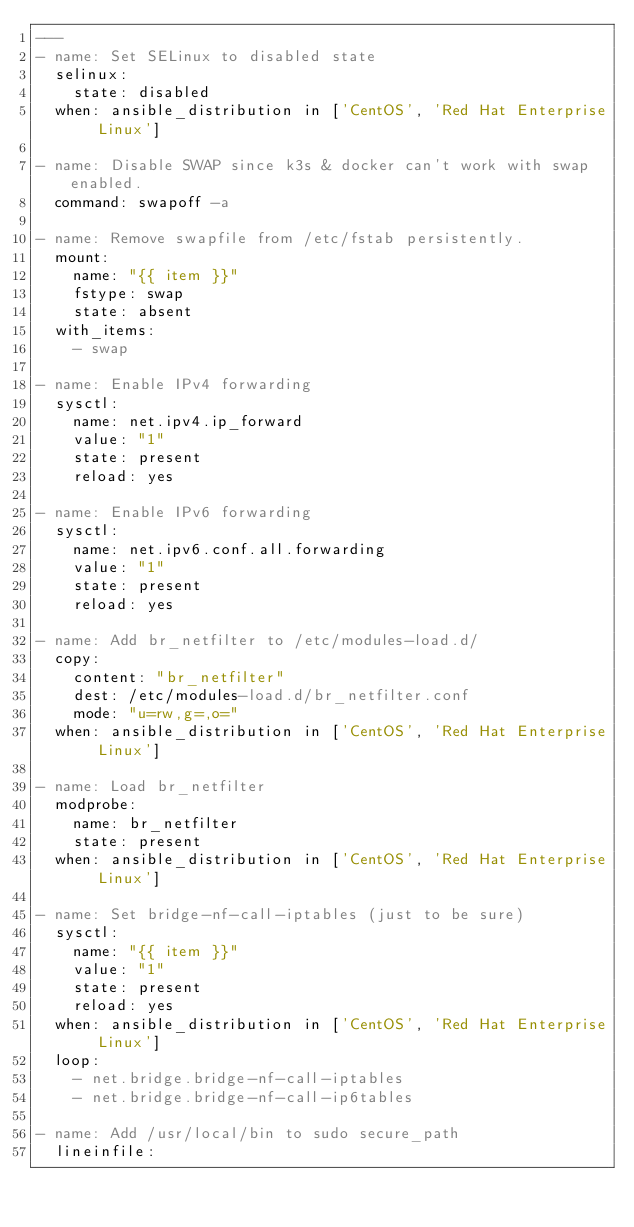<code> <loc_0><loc_0><loc_500><loc_500><_YAML_>---
- name: Set SELinux to disabled state
  selinux:
    state: disabled
  when: ansible_distribution in ['CentOS', 'Red Hat Enterprise Linux']

- name: Disable SWAP since k3s & docker can't work with swap enabled.
  command: swapoff -a

- name: Remove swapfile from /etc/fstab persistently.
  mount:
    name: "{{ item }}"
    fstype: swap
    state: absent
  with_items:
    - swap

- name: Enable IPv4 forwarding
  sysctl:
    name: net.ipv4.ip_forward
    value: "1"
    state: present
    reload: yes

- name: Enable IPv6 forwarding
  sysctl:
    name: net.ipv6.conf.all.forwarding
    value: "1"
    state: present
    reload: yes

- name: Add br_netfilter to /etc/modules-load.d/
  copy:
    content: "br_netfilter"
    dest: /etc/modules-load.d/br_netfilter.conf
    mode: "u=rw,g=,o="
  when: ansible_distribution in ['CentOS', 'Red Hat Enterprise Linux']

- name: Load br_netfilter
  modprobe:
    name: br_netfilter
    state: present
  when: ansible_distribution in ['CentOS', 'Red Hat Enterprise Linux']

- name: Set bridge-nf-call-iptables (just to be sure)
  sysctl:
    name: "{{ item }}"
    value: "1"
    state: present
    reload: yes
  when: ansible_distribution in ['CentOS', 'Red Hat Enterprise Linux']
  loop:
    - net.bridge.bridge-nf-call-iptables
    - net.bridge.bridge-nf-call-ip6tables

- name: Add /usr/local/bin to sudo secure_path
  lineinfile:</code> 